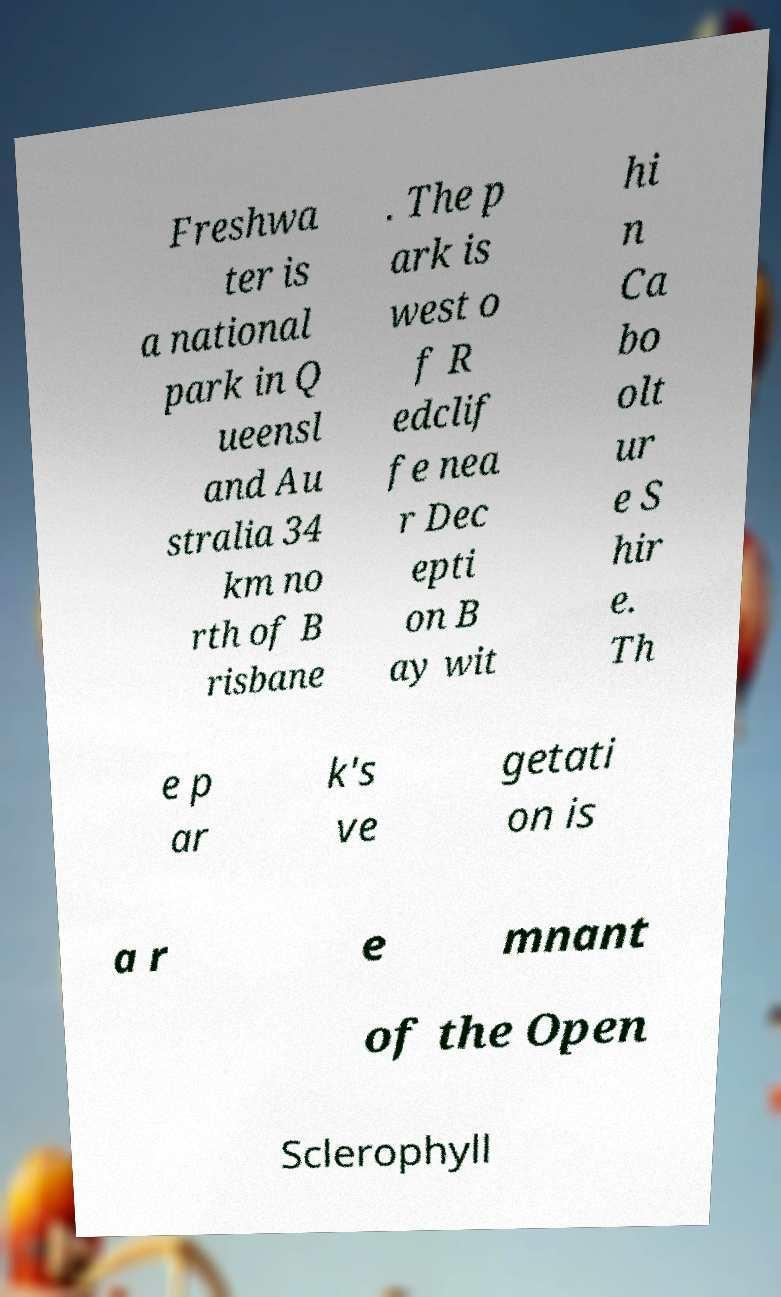For documentation purposes, I need the text within this image transcribed. Could you provide that? Freshwa ter is a national park in Q ueensl and Au stralia 34 km no rth of B risbane . The p ark is west o f R edclif fe nea r Dec epti on B ay wit hi n Ca bo olt ur e S hir e. Th e p ar k's ve getati on is a r e mnant of the Open Sclerophyll 